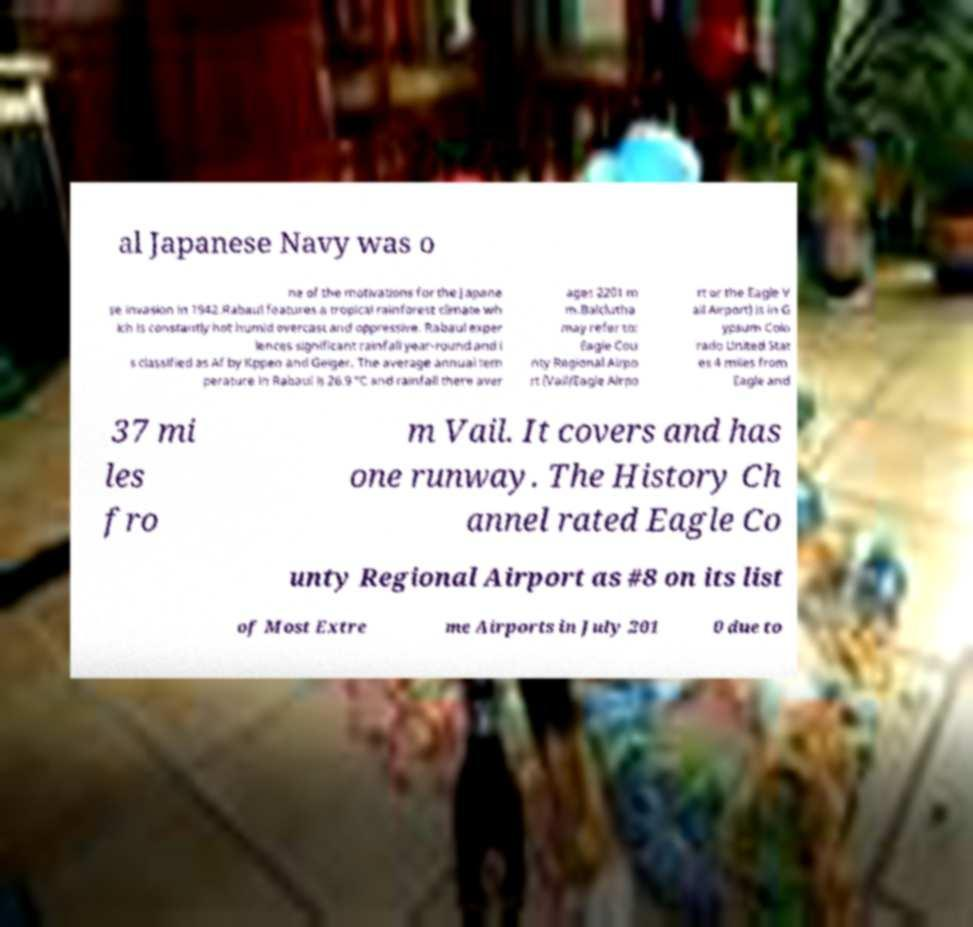Can you read and provide the text displayed in the image?This photo seems to have some interesting text. Can you extract and type it out for me? al Japanese Navy was o ne of the motivations for the Japane se invasion in 1942.Rabaul features a tropical rainforest climate wh ich is constantly hot humid overcast and oppressive. Rabaul exper iences significant rainfall year-round and i s classified as Af by Kppen and Geiger. The average annual tem perature in Rabaul is 26.9 °C and rainfall there aver ages 2201 m m.Balclutha may refer to: Eagle Cou nty Regional Airpo rt (Vail/Eagle Airpo rt or the Eagle V ail Airport) is in G ypsum Colo rado United Stat es 4 miles from Eagle and 37 mi les fro m Vail. It covers and has one runway. The History Ch annel rated Eagle Co unty Regional Airport as #8 on its list of Most Extre me Airports in July 201 0 due to 